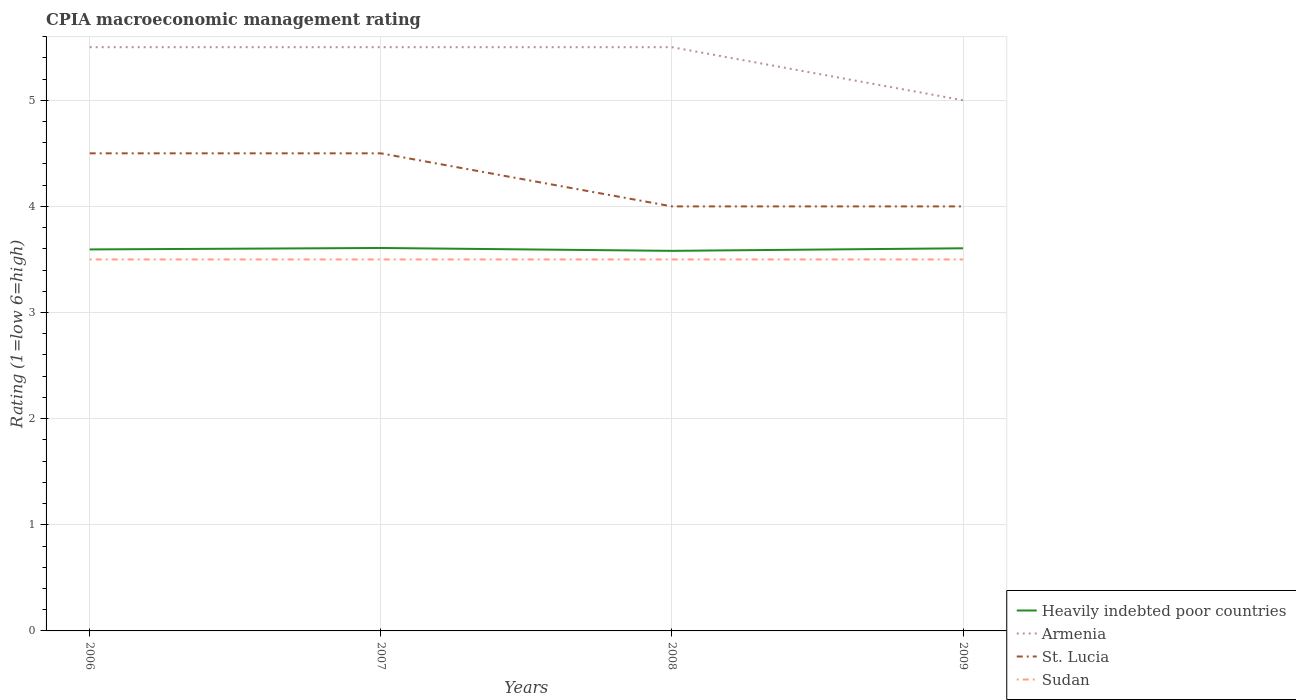How many different coloured lines are there?
Your response must be concise. 4. Does the line corresponding to Armenia intersect with the line corresponding to Heavily indebted poor countries?
Offer a very short reply. No. Across all years, what is the maximum CPIA rating in Armenia?
Give a very brief answer. 5. In which year was the CPIA rating in Armenia maximum?
Ensure brevity in your answer.  2009. What is the total CPIA rating in Armenia in the graph?
Offer a very short reply. 0. What is the difference between the highest and the second highest CPIA rating in Armenia?
Your answer should be compact. 0.5. What is the difference between the highest and the lowest CPIA rating in Heavily indebted poor countries?
Your answer should be very brief. 2. Is the CPIA rating in Armenia strictly greater than the CPIA rating in St. Lucia over the years?
Give a very brief answer. No. Where does the legend appear in the graph?
Keep it short and to the point. Bottom right. How many legend labels are there?
Make the answer very short. 4. How are the legend labels stacked?
Keep it short and to the point. Vertical. What is the title of the graph?
Keep it short and to the point. CPIA macroeconomic management rating. Does "South Africa" appear as one of the legend labels in the graph?
Make the answer very short. No. What is the label or title of the X-axis?
Keep it short and to the point. Years. What is the label or title of the Y-axis?
Offer a very short reply. Rating (1=low 6=high). What is the Rating (1=low 6=high) in Heavily indebted poor countries in 2006?
Give a very brief answer. 3.59. What is the Rating (1=low 6=high) in Heavily indebted poor countries in 2007?
Give a very brief answer. 3.61. What is the Rating (1=low 6=high) of St. Lucia in 2007?
Your answer should be compact. 4.5. What is the Rating (1=low 6=high) in Heavily indebted poor countries in 2008?
Keep it short and to the point. 3.58. What is the Rating (1=low 6=high) of St. Lucia in 2008?
Your response must be concise. 4. What is the Rating (1=low 6=high) in Sudan in 2008?
Provide a short and direct response. 3.5. What is the Rating (1=low 6=high) of Heavily indebted poor countries in 2009?
Your answer should be very brief. 3.61. What is the Rating (1=low 6=high) of St. Lucia in 2009?
Your answer should be compact. 4. Across all years, what is the maximum Rating (1=low 6=high) of Heavily indebted poor countries?
Offer a very short reply. 3.61. Across all years, what is the maximum Rating (1=low 6=high) of Armenia?
Offer a terse response. 5.5. Across all years, what is the minimum Rating (1=low 6=high) in Heavily indebted poor countries?
Keep it short and to the point. 3.58. Across all years, what is the minimum Rating (1=low 6=high) in Armenia?
Offer a terse response. 5. Across all years, what is the minimum Rating (1=low 6=high) in St. Lucia?
Make the answer very short. 4. Across all years, what is the minimum Rating (1=low 6=high) in Sudan?
Keep it short and to the point. 3.5. What is the total Rating (1=low 6=high) of Heavily indebted poor countries in the graph?
Offer a terse response. 14.39. What is the total Rating (1=low 6=high) of Armenia in the graph?
Your answer should be compact. 21.5. What is the total Rating (1=low 6=high) of Sudan in the graph?
Your response must be concise. 14. What is the difference between the Rating (1=low 6=high) in Heavily indebted poor countries in 2006 and that in 2007?
Your answer should be very brief. -0.01. What is the difference between the Rating (1=low 6=high) in St. Lucia in 2006 and that in 2007?
Provide a succinct answer. 0. What is the difference between the Rating (1=low 6=high) of Sudan in 2006 and that in 2007?
Provide a short and direct response. 0. What is the difference between the Rating (1=low 6=high) of Heavily indebted poor countries in 2006 and that in 2008?
Ensure brevity in your answer.  0.01. What is the difference between the Rating (1=low 6=high) of Armenia in 2006 and that in 2008?
Provide a short and direct response. 0. What is the difference between the Rating (1=low 6=high) in St. Lucia in 2006 and that in 2008?
Provide a short and direct response. 0.5. What is the difference between the Rating (1=low 6=high) of Sudan in 2006 and that in 2008?
Offer a very short reply. 0. What is the difference between the Rating (1=low 6=high) in Heavily indebted poor countries in 2006 and that in 2009?
Provide a succinct answer. -0.01. What is the difference between the Rating (1=low 6=high) in St. Lucia in 2006 and that in 2009?
Your answer should be very brief. 0.5. What is the difference between the Rating (1=low 6=high) of Sudan in 2006 and that in 2009?
Give a very brief answer. 0. What is the difference between the Rating (1=low 6=high) in Heavily indebted poor countries in 2007 and that in 2008?
Ensure brevity in your answer.  0.03. What is the difference between the Rating (1=low 6=high) of Armenia in 2007 and that in 2008?
Ensure brevity in your answer.  0. What is the difference between the Rating (1=low 6=high) of St. Lucia in 2007 and that in 2008?
Offer a terse response. 0.5. What is the difference between the Rating (1=low 6=high) in Sudan in 2007 and that in 2008?
Keep it short and to the point. 0. What is the difference between the Rating (1=low 6=high) in Heavily indebted poor countries in 2007 and that in 2009?
Offer a terse response. 0. What is the difference between the Rating (1=low 6=high) of Armenia in 2007 and that in 2009?
Keep it short and to the point. 0.5. What is the difference between the Rating (1=low 6=high) of St. Lucia in 2007 and that in 2009?
Provide a succinct answer. 0.5. What is the difference between the Rating (1=low 6=high) of Heavily indebted poor countries in 2008 and that in 2009?
Provide a succinct answer. -0.02. What is the difference between the Rating (1=low 6=high) in Sudan in 2008 and that in 2009?
Keep it short and to the point. 0. What is the difference between the Rating (1=low 6=high) of Heavily indebted poor countries in 2006 and the Rating (1=low 6=high) of Armenia in 2007?
Provide a short and direct response. -1.91. What is the difference between the Rating (1=low 6=high) of Heavily indebted poor countries in 2006 and the Rating (1=low 6=high) of St. Lucia in 2007?
Ensure brevity in your answer.  -0.91. What is the difference between the Rating (1=low 6=high) of Heavily indebted poor countries in 2006 and the Rating (1=low 6=high) of Sudan in 2007?
Provide a succinct answer. 0.09. What is the difference between the Rating (1=low 6=high) of Armenia in 2006 and the Rating (1=low 6=high) of St. Lucia in 2007?
Offer a terse response. 1. What is the difference between the Rating (1=low 6=high) in Armenia in 2006 and the Rating (1=low 6=high) in Sudan in 2007?
Provide a succinct answer. 2. What is the difference between the Rating (1=low 6=high) in St. Lucia in 2006 and the Rating (1=low 6=high) in Sudan in 2007?
Give a very brief answer. 1. What is the difference between the Rating (1=low 6=high) of Heavily indebted poor countries in 2006 and the Rating (1=low 6=high) of Armenia in 2008?
Your answer should be compact. -1.91. What is the difference between the Rating (1=low 6=high) of Heavily indebted poor countries in 2006 and the Rating (1=low 6=high) of St. Lucia in 2008?
Offer a terse response. -0.41. What is the difference between the Rating (1=low 6=high) in Heavily indebted poor countries in 2006 and the Rating (1=low 6=high) in Sudan in 2008?
Provide a succinct answer. 0.09. What is the difference between the Rating (1=low 6=high) in Armenia in 2006 and the Rating (1=low 6=high) in St. Lucia in 2008?
Offer a very short reply. 1.5. What is the difference between the Rating (1=low 6=high) of Armenia in 2006 and the Rating (1=low 6=high) of Sudan in 2008?
Offer a terse response. 2. What is the difference between the Rating (1=low 6=high) of Heavily indebted poor countries in 2006 and the Rating (1=low 6=high) of Armenia in 2009?
Your response must be concise. -1.41. What is the difference between the Rating (1=low 6=high) of Heavily indebted poor countries in 2006 and the Rating (1=low 6=high) of St. Lucia in 2009?
Your response must be concise. -0.41. What is the difference between the Rating (1=low 6=high) in Heavily indebted poor countries in 2006 and the Rating (1=low 6=high) in Sudan in 2009?
Give a very brief answer. 0.09. What is the difference between the Rating (1=low 6=high) in St. Lucia in 2006 and the Rating (1=low 6=high) in Sudan in 2009?
Your answer should be compact. 1. What is the difference between the Rating (1=low 6=high) of Heavily indebted poor countries in 2007 and the Rating (1=low 6=high) of Armenia in 2008?
Make the answer very short. -1.89. What is the difference between the Rating (1=low 6=high) in Heavily indebted poor countries in 2007 and the Rating (1=low 6=high) in St. Lucia in 2008?
Give a very brief answer. -0.39. What is the difference between the Rating (1=low 6=high) of Heavily indebted poor countries in 2007 and the Rating (1=low 6=high) of Sudan in 2008?
Your answer should be compact. 0.11. What is the difference between the Rating (1=low 6=high) of St. Lucia in 2007 and the Rating (1=low 6=high) of Sudan in 2008?
Offer a terse response. 1. What is the difference between the Rating (1=low 6=high) in Heavily indebted poor countries in 2007 and the Rating (1=low 6=high) in Armenia in 2009?
Offer a terse response. -1.39. What is the difference between the Rating (1=low 6=high) of Heavily indebted poor countries in 2007 and the Rating (1=low 6=high) of St. Lucia in 2009?
Give a very brief answer. -0.39. What is the difference between the Rating (1=low 6=high) of Heavily indebted poor countries in 2007 and the Rating (1=low 6=high) of Sudan in 2009?
Provide a short and direct response. 0.11. What is the difference between the Rating (1=low 6=high) of Armenia in 2007 and the Rating (1=low 6=high) of St. Lucia in 2009?
Offer a terse response. 1.5. What is the difference between the Rating (1=low 6=high) in Armenia in 2007 and the Rating (1=low 6=high) in Sudan in 2009?
Your response must be concise. 2. What is the difference between the Rating (1=low 6=high) of Heavily indebted poor countries in 2008 and the Rating (1=low 6=high) of Armenia in 2009?
Give a very brief answer. -1.42. What is the difference between the Rating (1=low 6=high) in Heavily indebted poor countries in 2008 and the Rating (1=low 6=high) in St. Lucia in 2009?
Ensure brevity in your answer.  -0.42. What is the difference between the Rating (1=low 6=high) in Heavily indebted poor countries in 2008 and the Rating (1=low 6=high) in Sudan in 2009?
Your response must be concise. 0.08. What is the difference between the Rating (1=low 6=high) of Armenia in 2008 and the Rating (1=low 6=high) of St. Lucia in 2009?
Offer a terse response. 1.5. What is the difference between the Rating (1=low 6=high) of Armenia in 2008 and the Rating (1=low 6=high) of Sudan in 2009?
Your response must be concise. 2. What is the difference between the Rating (1=low 6=high) of St. Lucia in 2008 and the Rating (1=low 6=high) of Sudan in 2009?
Provide a short and direct response. 0.5. What is the average Rating (1=low 6=high) in Heavily indebted poor countries per year?
Your answer should be very brief. 3.6. What is the average Rating (1=low 6=high) of Armenia per year?
Offer a terse response. 5.38. What is the average Rating (1=low 6=high) in St. Lucia per year?
Keep it short and to the point. 4.25. What is the average Rating (1=low 6=high) of Sudan per year?
Your answer should be very brief. 3.5. In the year 2006, what is the difference between the Rating (1=low 6=high) in Heavily indebted poor countries and Rating (1=low 6=high) in Armenia?
Your response must be concise. -1.91. In the year 2006, what is the difference between the Rating (1=low 6=high) of Heavily indebted poor countries and Rating (1=low 6=high) of St. Lucia?
Give a very brief answer. -0.91. In the year 2006, what is the difference between the Rating (1=low 6=high) in Heavily indebted poor countries and Rating (1=low 6=high) in Sudan?
Keep it short and to the point. 0.09. In the year 2007, what is the difference between the Rating (1=low 6=high) of Heavily indebted poor countries and Rating (1=low 6=high) of Armenia?
Make the answer very short. -1.89. In the year 2007, what is the difference between the Rating (1=low 6=high) in Heavily indebted poor countries and Rating (1=low 6=high) in St. Lucia?
Ensure brevity in your answer.  -0.89. In the year 2007, what is the difference between the Rating (1=low 6=high) of Heavily indebted poor countries and Rating (1=low 6=high) of Sudan?
Your answer should be compact. 0.11. In the year 2007, what is the difference between the Rating (1=low 6=high) of Armenia and Rating (1=low 6=high) of St. Lucia?
Your answer should be compact. 1. In the year 2007, what is the difference between the Rating (1=low 6=high) of Armenia and Rating (1=low 6=high) of Sudan?
Keep it short and to the point. 2. In the year 2008, what is the difference between the Rating (1=low 6=high) in Heavily indebted poor countries and Rating (1=low 6=high) in Armenia?
Your answer should be very brief. -1.92. In the year 2008, what is the difference between the Rating (1=low 6=high) of Heavily indebted poor countries and Rating (1=low 6=high) of St. Lucia?
Provide a succinct answer. -0.42. In the year 2008, what is the difference between the Rating (1=low 6=high) of Heavily indebted poor countries and Rating (1=low 6=high) of Sudan?
Make the answer very short. 0.08. In the year 2008, what is the difference between the Rating (1=low 6=high) in Armenia and Rating (1=low 6=high) in St. Lucia?
Your answer should be compact. 1.5. In the year 2008, what is the difference between the Rating (1=low 6=high) of St. Lucia and Rating (1=low 6=high) of Sudan?
Your answer should be compact. 0.5. In the year 2009, what is the difference between the Rating (1=low 6=high) of Heavily indebted poor countries and Rating (1=low 6=high) of Armenia?
Ensure brevity in your answer.  -1.39. In the year 2009, what is the difference between the Rating (1=low 6=high) in Heavily indebted poor countries and Rating (1=low 6=high) in St. Lucia?
Offer a very short reply. -0.39. In the year 2009, what is the difference between the Rating (1=low 6=high) of Heavily indebted poor countries and Rating (1=low 6=high) of Sudan?
Your answer should be compact. 0.11. In the year 2009, what is the difference between the Rating (1=low 6=high) in Armenia and Rating (1=low 6=high) in St. Lucia?
Ensure brevity in your answer.  1. What is the ratio of the Rating (1=low 6=high) in St. Lucia in 2006 to that in 2007?
Give a very brief answer. 1. What is the ratio of the Rating (1=low 6=high) in Heavily indebted poor countries in 2006 to that in 2008?
Your answer should be compact. 1. What is the ratio of the Rating (1=low 6=high) of Armenia in 2006 to that in 2008?
Your answer should be very brief. 1. What is the ratio of the Rating (1=low 6=high) in Heavily indebted poor countries in 2006 to that in 2009?
Your response must be concise. 1. What is the ratio of the Rating (1=low 6=high) in Armenia in 2006 to that in 2009?
Make the answer very short. 1.1. What is the ratio of the Rating (1=low 6=high) of Sudan in 2006 to that in 2009?
Your answer should be compact. 1. What is the ratio of the Rating (1=low 6=high) of Heavily indebted poor countries in 2007 to that in 2008?
Offer a terse response. 1.01. What is the ratio of the Rating (1=low 6=high) in Heavily indebted poor countries in 2007 to that in 2009?
Keep it short and to the point. 1. What is the ratio of the Rating (1=low 6=high) of Heavily indebted poor countries in 2008 to that in 2009?
Make the answer very short. 0.99. What is the ratio of the Rating (1=low 6=high) of Armenia in 2008 to that in 2009?
Your response must be concise. 1.1. What is the ratio of the Rating (1=low 6=high) of St. Lucia in 2008 to that in 2009?
Ensure brevity in your answer.  1. What is the ratio of the Rating (1=low 6=high) of Sudan in 2008 to that in 2009?
Give a very brief answer. 1. What is the difference between the highest and the second highest Rating (1=low 6=high) of Heavily indebted poor countries?
Make the answer very short. 0. What is the difference between the highest and the lowest Rating (1=low 6=high) of Heavily indebted poor countries?
Provide a succinct answer. 0.03. 